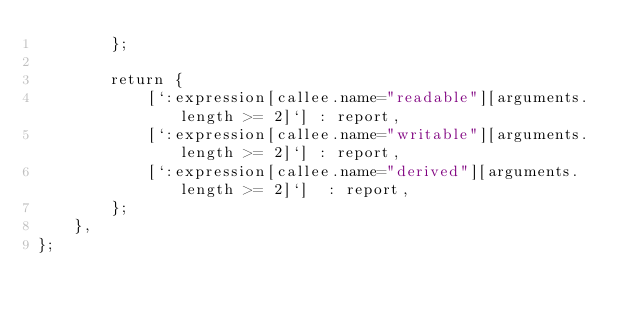<code> <loc_0><loc_0><loc_500><loc_500><_JavaScript_>        };

        return {
            [`:expression[callee.name="readable"][arguments.length >= 2]`] : report,
            [`:expression[callee.name="writable"][arguments.length >= 2]`] : report,
            [`:expression[callee.name="derived"][arguments.length >= 2]`]  : report,
        };
    },
};
</code> 